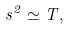Convert formula to latex. <formula><loc_0><loc_0><loc_500><loc_500>s ^ { 2 } \simeq T ,</formula> 